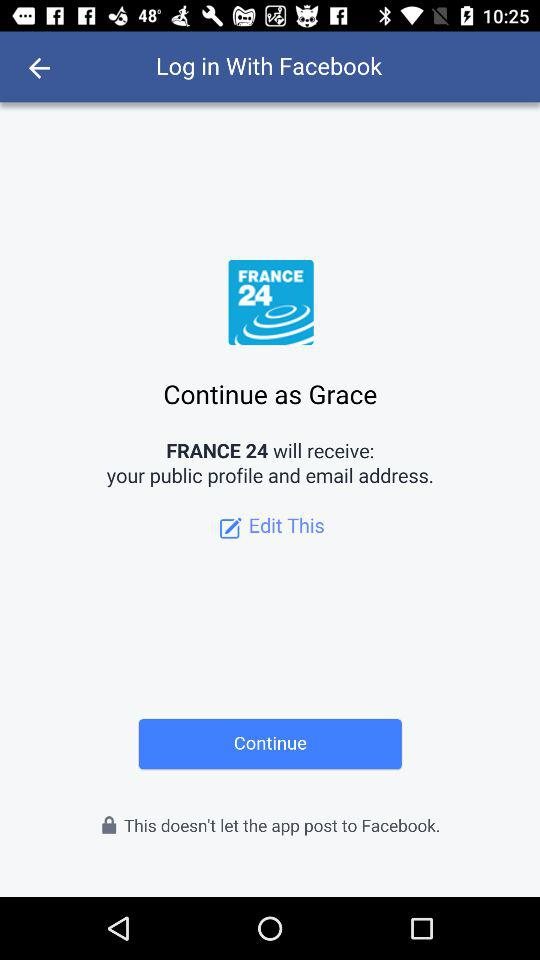What is the login name? The login name is "Grace". 